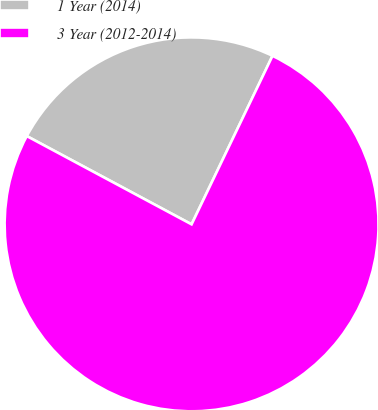<chart> <loc_0><loc_0><loc_500><loc_500><pie_chart><fcel>1 Year (2014)<fcel>3 Year (2012-2014)<nl><fcel>24.3%<fcel>75.7%<nl></chart> 